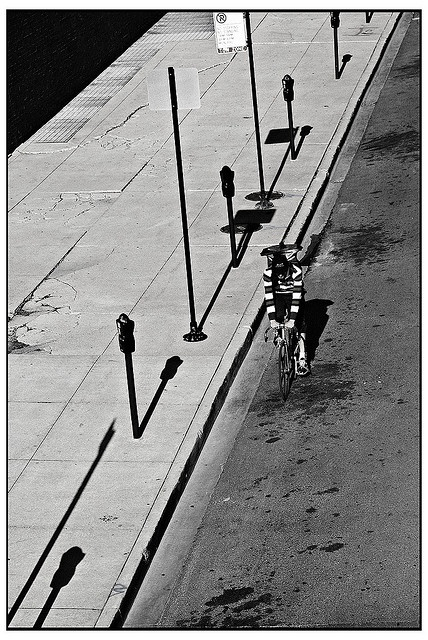Describe the objects in this image and their specific colors. I can see people in white, black, gray, and darkgray tones, bicycle in white, black, gray, darkgray, and lightgray tones, parking meter in white, black, lightgray, gray, and darkgray tones, parking meter in white, black, darkgray, gray, and lightgray tones, and parking meter in white, black, and gray tones in this image. 